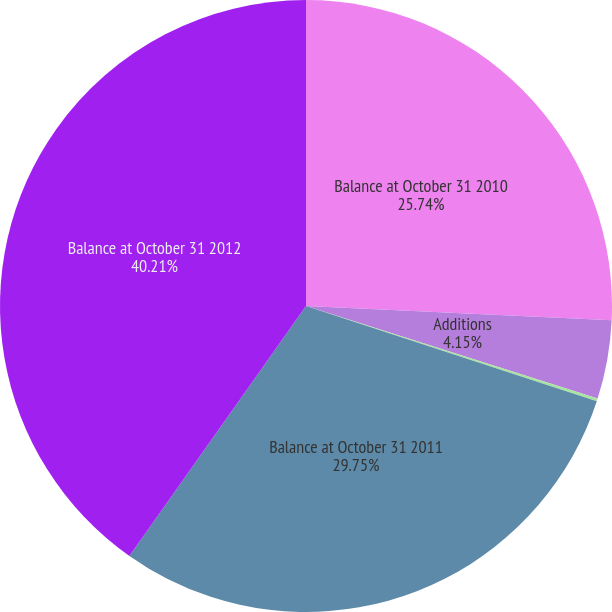Convert chart to OTSL. <chart><loc_0><loc_0><loc_500><loc_500><pie_chart><fcel>Balance at October 31 2010<fcel>Additions<fcel>Other adjustments(1)<fcel>Balance at October 31 2011<fcel>Balance at October 31 2012<nl><fcel>25.74%<fcel>4.15%<fcel>0.15%<fcel>29.75%<fcel>40.21%<nl></chart> 